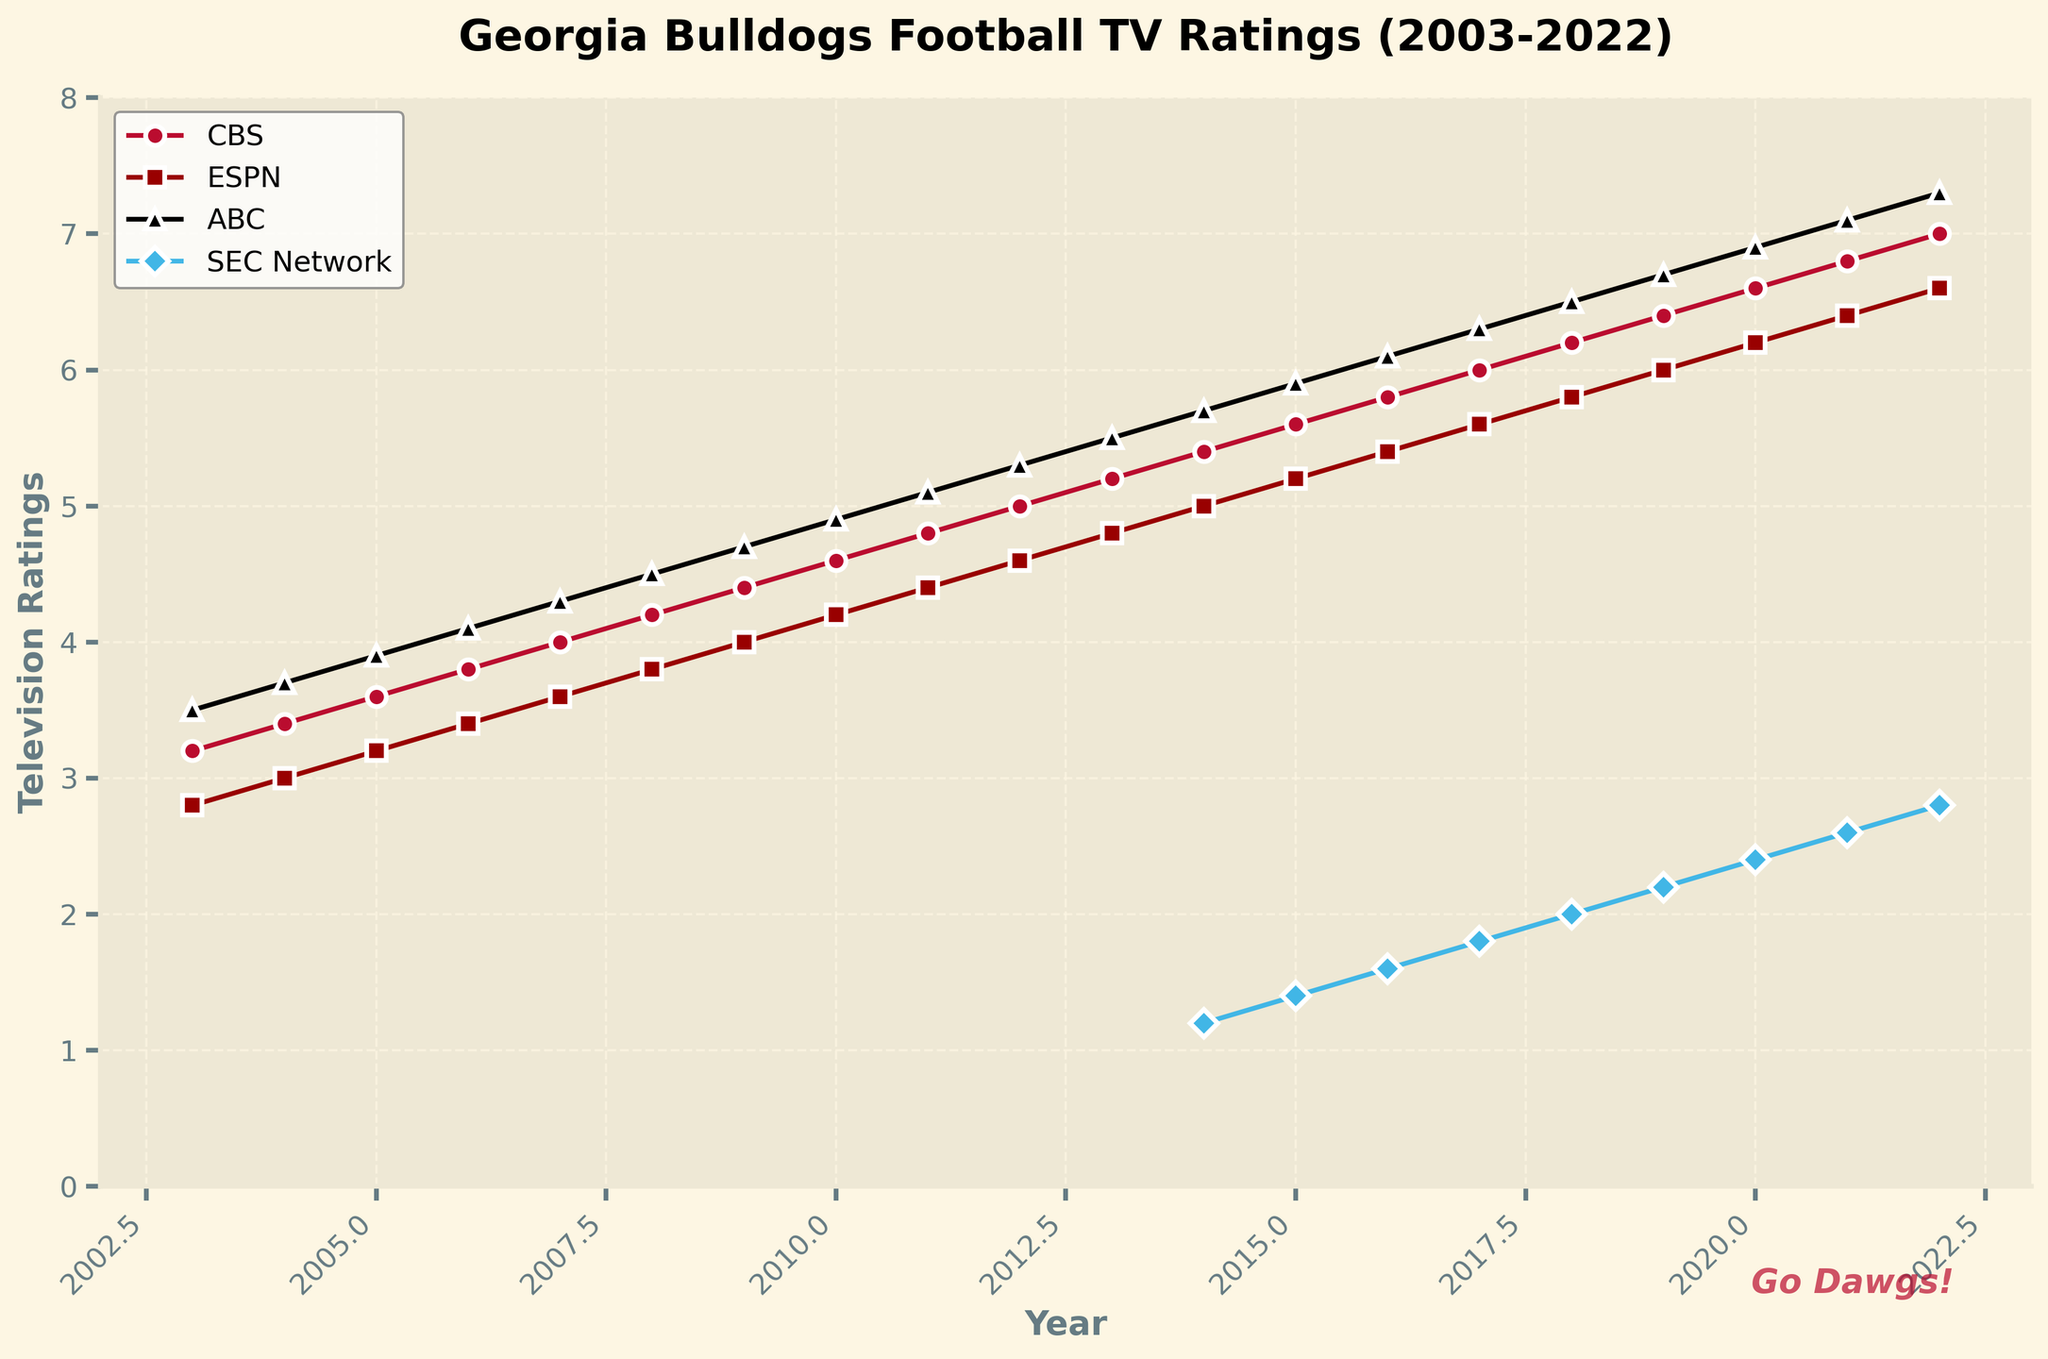What was the television rating for the Georgia Bulldogs on CBS in 2003? Locate the line representing CBS, find the point corresponding to the year 2003, and note the rating value.
Answer: 3.2 Which network showed the highest rating in 2022? Check the ratings for each network at the year 2022 and identify the highest value.
Answer: ABC By how much did ESPN's television rating increase from 2003 to 2013? Subtract the rating in 2003 from the rating in 2013 for ESPN.
Answer: 2.0 How did the ratings for the SEC Network change from 2014 to 2022? Identify the SEC Network's ratings for 2014 and 2022 and describe the trend over the period.
Answer: Increased from 1.2 to 2.8 Which network had the smallest increase in ratings from 2003 to 2009? Calculate the rating differences for CBS, ESPN, and ABC from 2003 to 2009 and identify the smallest increase.
Answer: CBS In which year did ABC's ratings first exceed 5.0? Locate the year in the ABC line where the rating value first surpasses 5.0.
Answer: 2011 How many years did it take for CBS's ratings to rise from 4.0 to 6.0? Find the years where CBS's ratings were 4.0 and 6.0, then compute the difference.
Answer: 10 years If the SEC Network's ratings had grown at the same rate from 2014 to 2022 as ABC's ratings from 2003 to 2011, what would have been the 2022 rating for the SEC Network? Calculate the rate of increase for ABC from 2003 to 2011 and apply the same rate to the SEC Network from 2014 to 2022.
Answer: 3.44 What was the average rating for ABC from 2003 to 2022? Sum all the ratings for ABC from 2003 to 2022 and divide by the number of years (20).
Answer: 5.2 Which year saw the largest year-over-year increase in CBS ratings? Compute the rating differences for CBS between consecutive years and identify the largest increase.
Answer: 2003 to 2004 